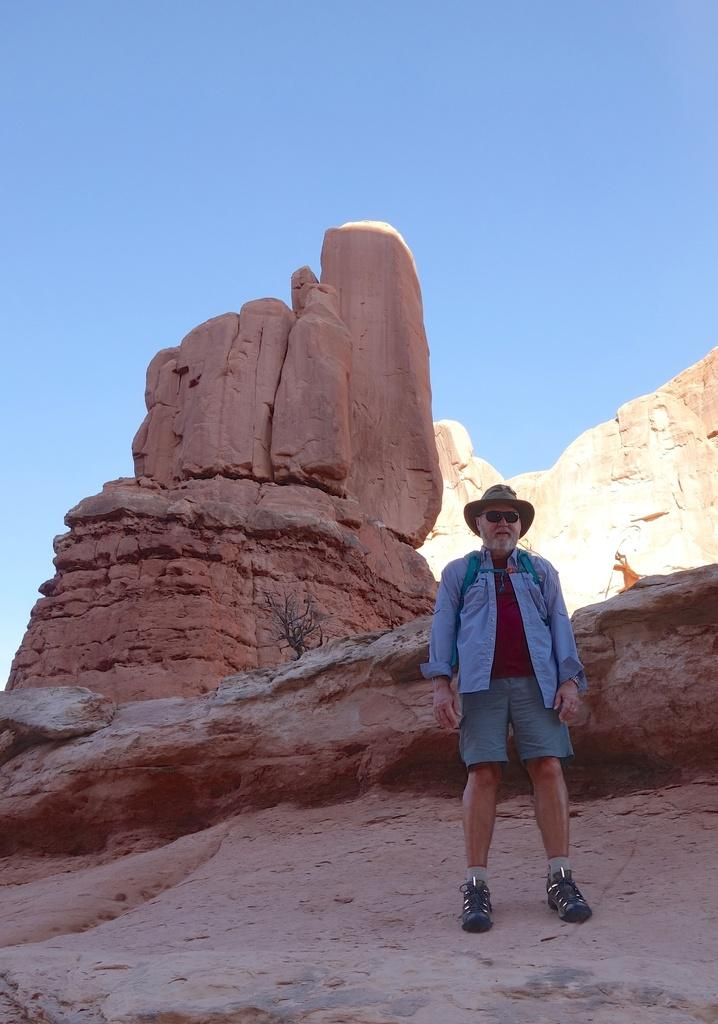What is the main subject of the image? There is a man standing in the image. Can you describe the man's attire? The man is wearing a hat, shades, shorts, and footwear. What can be seen in the background of the image? There is a mountain and the sky visible in the background of the image. How many pies is the man holding in the image? There are no pies present in the image. Can you describe the kitty sitting next to the man in the image? There is no kitty present in the image. 